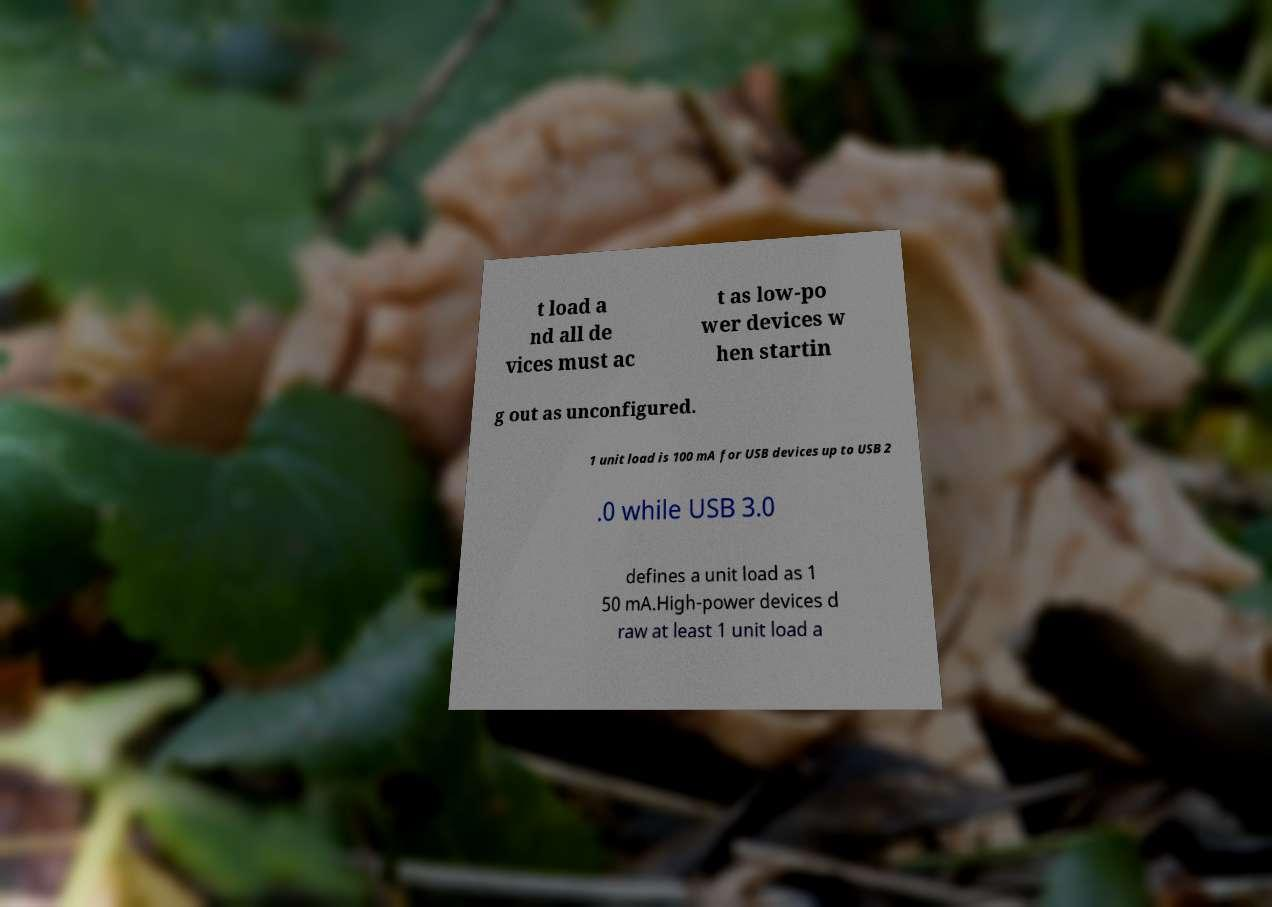For documentation purposes, I need the text within this image transcribed. Could you provide that? t load a nd all de vices must ac t as low-po wer devices w hen startin g out as unconfigured. 1 unit load is 100 mA for USB devices up to USB 2 .0 while USB 3.0 defines a unit load as 1 50 mA.High-power devices d raw at least 1 unit load a 